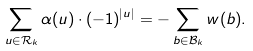Convert formula to latex. <formula><loc_0><loc_0><loc_500><loc_500>\sum _ { u \in \mathcal { \mathcal { R } } _ { k } } \alpha ( u ) \cdot ( - 1 ) ^ { | u | } = - \sum _ { b \in \mathcal { B } _ { k } } w ( b ) .</formula> 